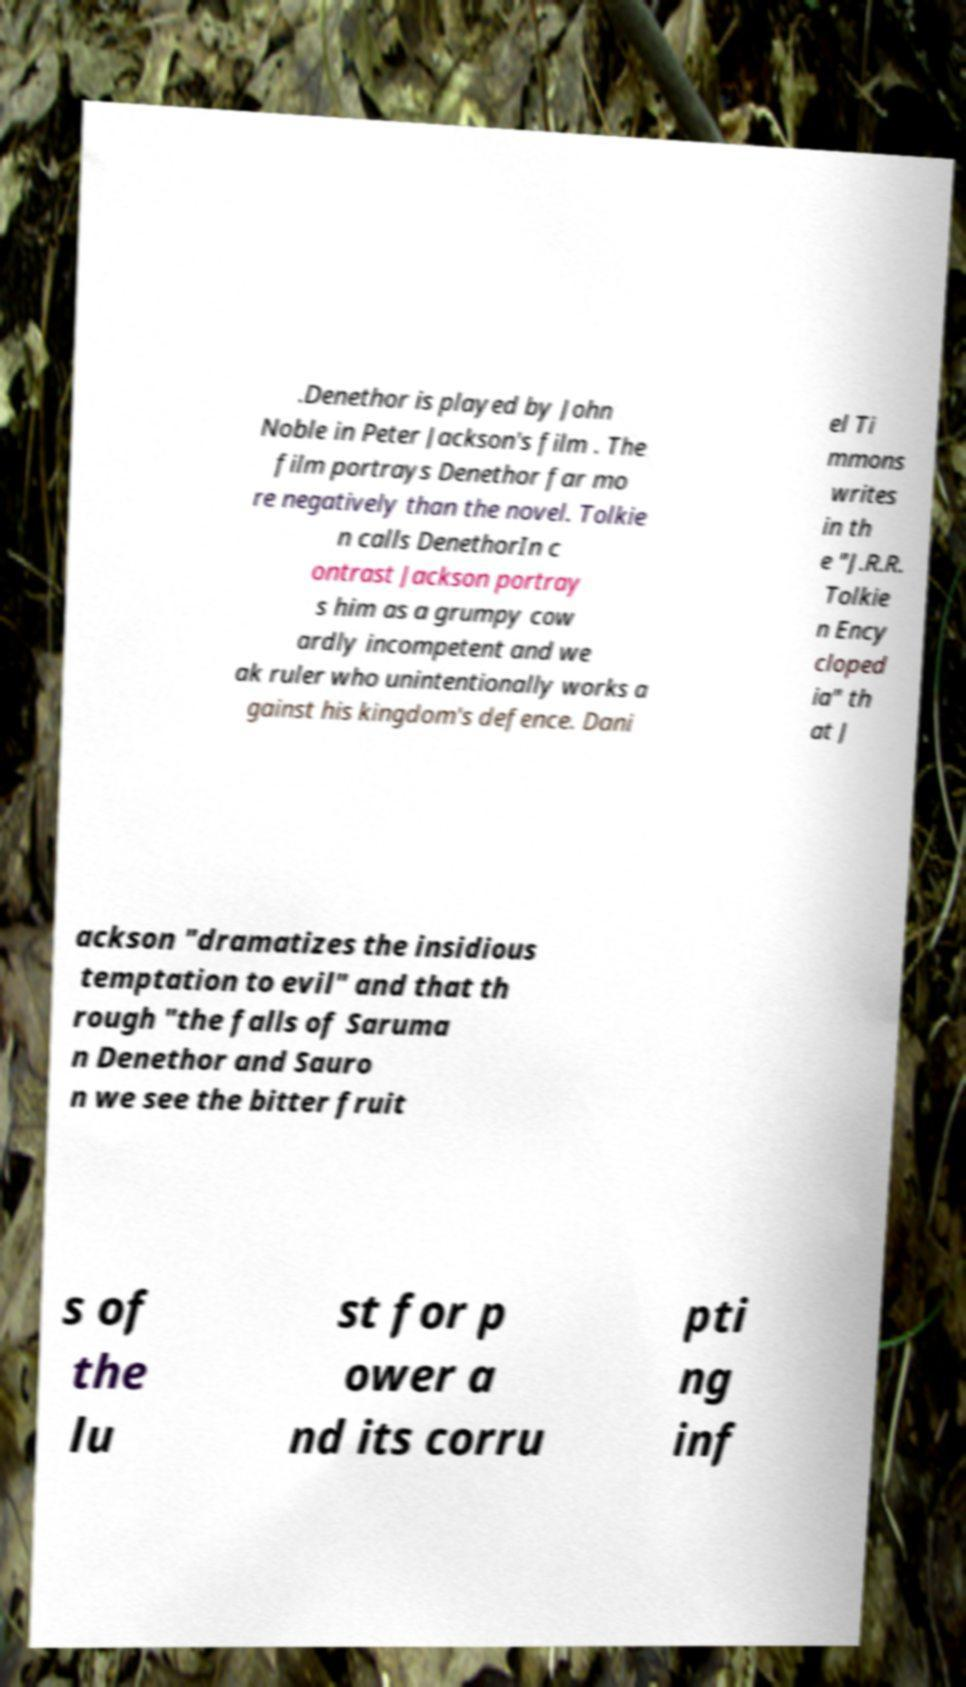There's text embedded in this image that I need extracted. Can you transcribe it verbatim? .Denethor is played by John Noble in Peter Jackson's film . The film portrays Denethor far mo re negatively than the novel. Tolkie n calls DenethorIn c ontrast Jackson portray s him as a grumpy cow ardly incompetent and we ak ruler who unintentionally works a gainst his kingdom's defence. Dani el Ti mmons writes in th e "J.R.R. Tolkie n Ency cloped ia" th at J ackson "dramatizes the insidious temptation to evil" and that th rough "the falls of Saruma n Denethor and Sauro n we see the bitter fruit s of the lu st for p ower a nd its corru pti ng inf 